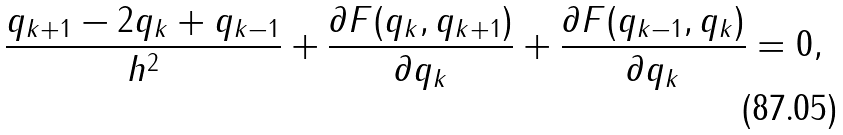Convert formula to latex. <formula><loc_0><loc_0><loc_500><loc_500>\frac { q _ { k + 1 } - 2 q _ { k } + q _ { k - 1 } } { h ^ { 2 } } + \frac { \partial F ( q _ { k } , q _ { k + 1 } ) } { \partial q _ { k } } + \frac { \partial F ( q _ { k - 1 } , q _ { k } ) } { \partial q _ { k } } = 0 ,</formula> 